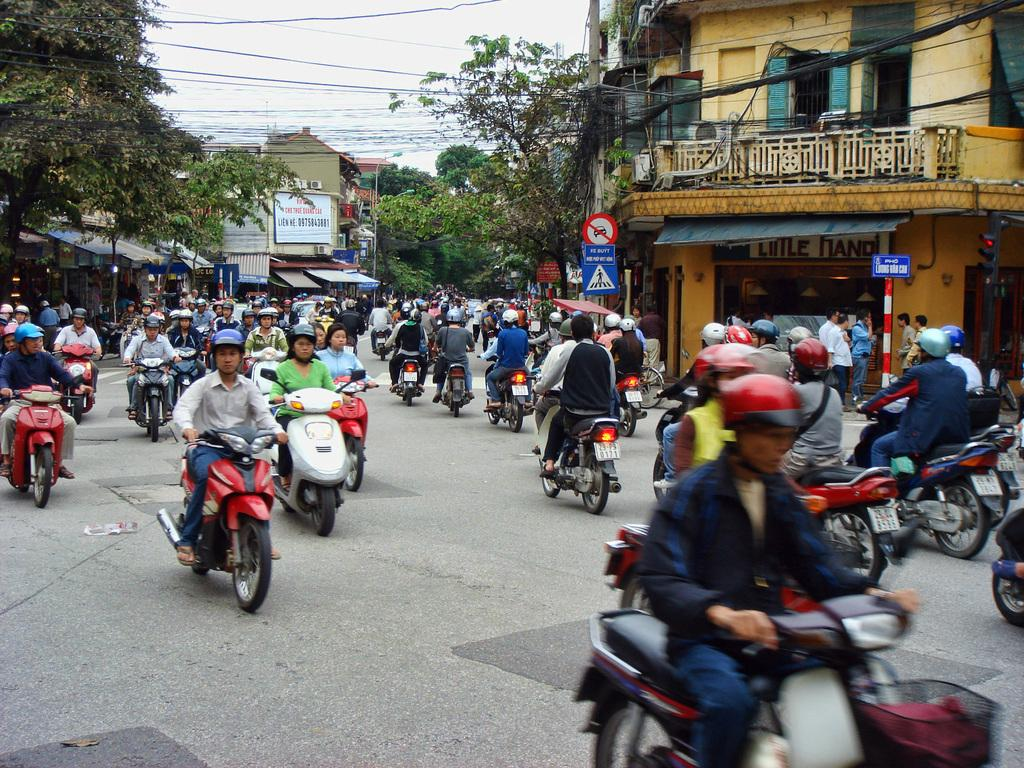What are the people in the image doing? The people in the image are sitting on bikes. Where are the people located in the image? The people are on a path. What can be seen in the background of the image? There are buildings, trees, and wires in the background of the image. Are there any other people visible in the image? Yes, there are people visible in the background of the image. What type of breakfast is being served on the bikes in the image? There is no breakfast visible in the image; the people are sitting on bikes without any food or beverages. How many cats can be seen riding in the car in the background of the image? There is no car or cats present in the image. 